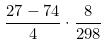<formula> <loc_0><loc_0><loc_500><loc_500>\frac { 2 7 - 7 4 } { 4 } \cdot \frac { 8 } { 2 9 8 }</formula> 